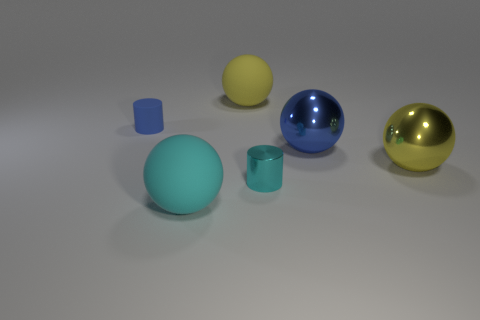Subtract all gray balls. Subtract all gray blocks. How many balls are left? 4 Add 1 blue matte balls. How many objects exist? 7 Subtract all spheres. How many objects are left? 2 Subtract all large rubber balls. Subtract all shiny spheres. How many objects are left? 2 Add 3 big rubber things. How many big rubber things are left? 5 Add 1 tiny metallic objects. How many tiny metallic objects exist? 2 Subtract 0 purple blocks. How many objects are left? 6 